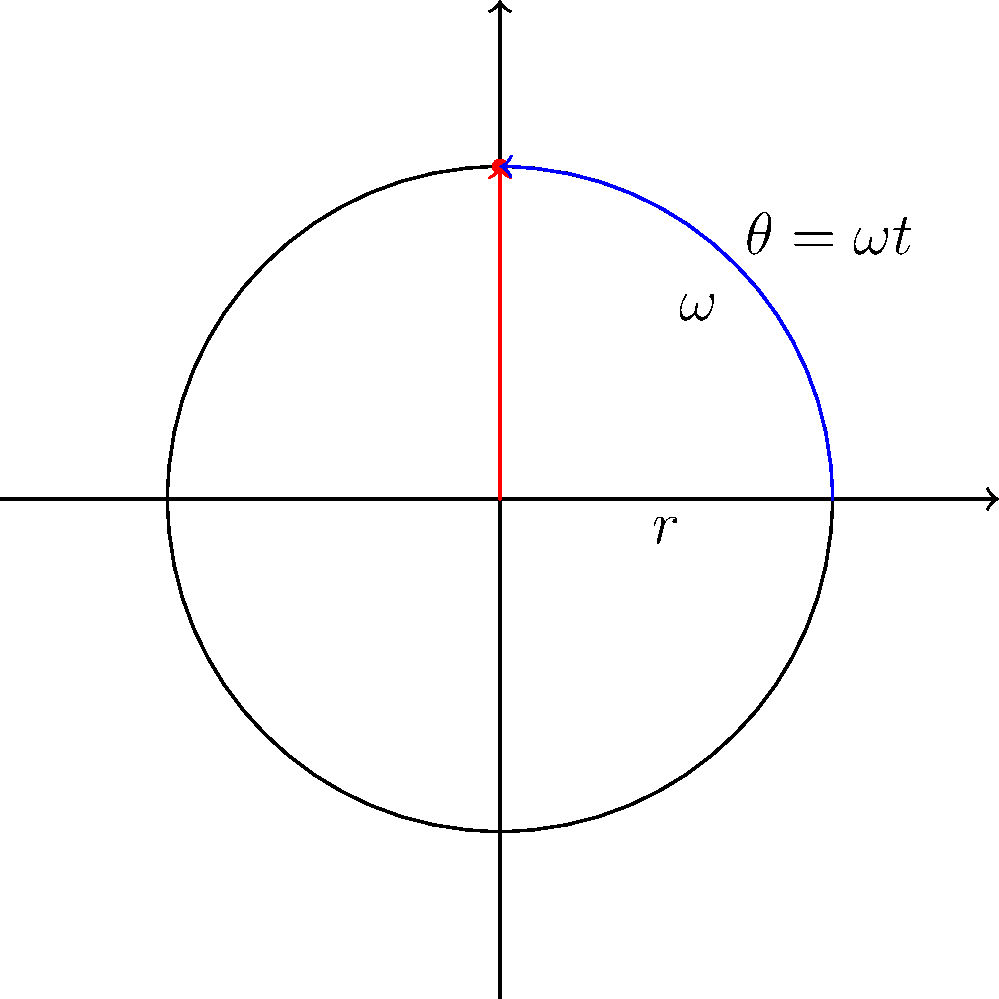During a crucial game against the Manhattan Jaspers in the 1994-95 season, you intercepted a pass and got hold of the basketball. As you prepared to make a quick decision, you noticed the ball was spinning. If the basketball has a mass of 0.62 kg, a radius of 0.12 m, and is spinning at 4 revolutions per second, what is its angular momentum? To calculate the angular momentum of the spinning basketball, we'll follow these steps:

1) First, we need to calculate the moment of inertia (I) of the basketball. For a solid sphere, the moment of inertia is given by:

   $I = \frac{2}{5}mr^2$

   where $m$ is the mass and $r$ is the radius.

2) We're given:
   $m = 0.62$ kg
   $r = 0.12$ m

3) Substituting these values:

   $I = \frac{2}{5} \times 0.62 \times 0.12^2 = 0.001786$ kg⋅m²

4) Next, we need to convert the angular velocity from revolutions per second to radians per second:

   $\omega = 4$ rev/s $\times 2\pi$ rad/rev $= 8\pi$ rad/s

5) The angular momentum (L) is given by:

   $L = I\omega$

6) Substituting our calculated values:

   $L = 0.001786 \times 8\pi = 0.0448$ kg⋅m²/s

Therefore, the angular momentum of the spinning basketball is approximately 0.0448 kg⋅m²/s.
Answer: 0.0448 kg⋅m²/s 